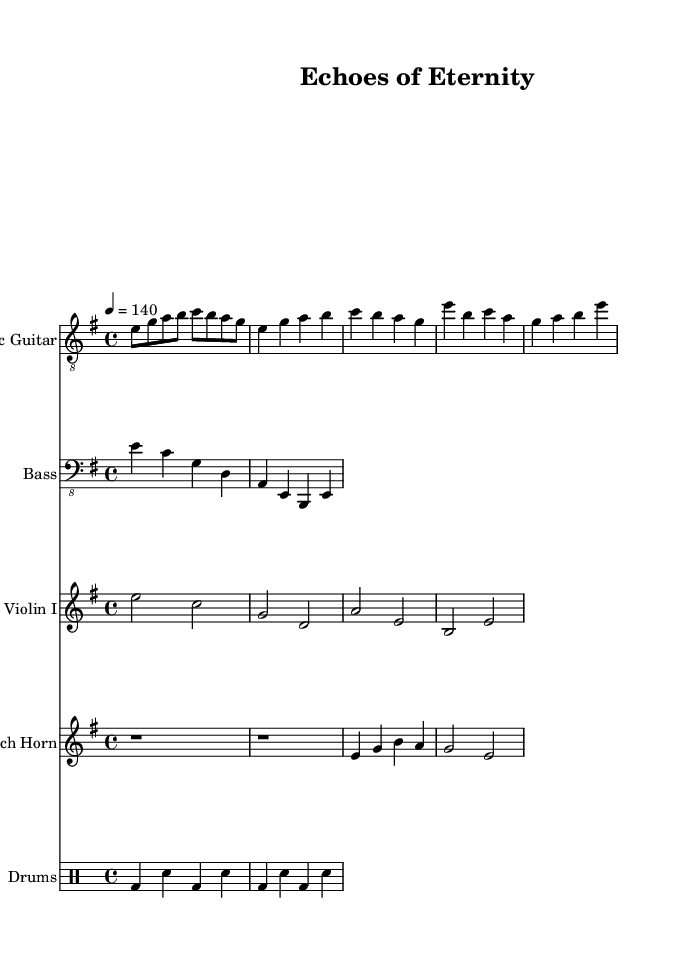What is the key signature of this music? The key signature indicated at the beginning of the piece is E minor, which has one sharp (F#).
Answer: E minor What is the time signature of this music? The time signature is displayed at the beginning of the score, shown as 4/4, indicating four beats per measure.
Answer: 4/4 What is the tempo marking for this piece? The tempo marking is found at the start of the score, showing "4 = 140," which indicates the metronome mark of 140 beats per minute.
Answer: 140 What is the primary instrument in this composition? The piece features an electric guitar as one of the main instruments, and it is labeled clearly at the top of the staff.
Answer: Electric Guitar How many measures are in the verse section? By counting the measures in the verse part section that starts with E4, there are a total of two measures presented in that section.
Answer: 2 What notable element differentiates the chorus from the verse? The chorus contains a higher vocal range indicated by the notes being in the octave marked with primes, and features a different rhythmic pattern, highlighting a shift in intensity.
Answer: Higher vocal range What type of melodic line does the violin imitate? The violin plays sustained chords that follow the same harmony established by the chord progression and supporting motifs in the other instruments.
Answer: Sustained chords 